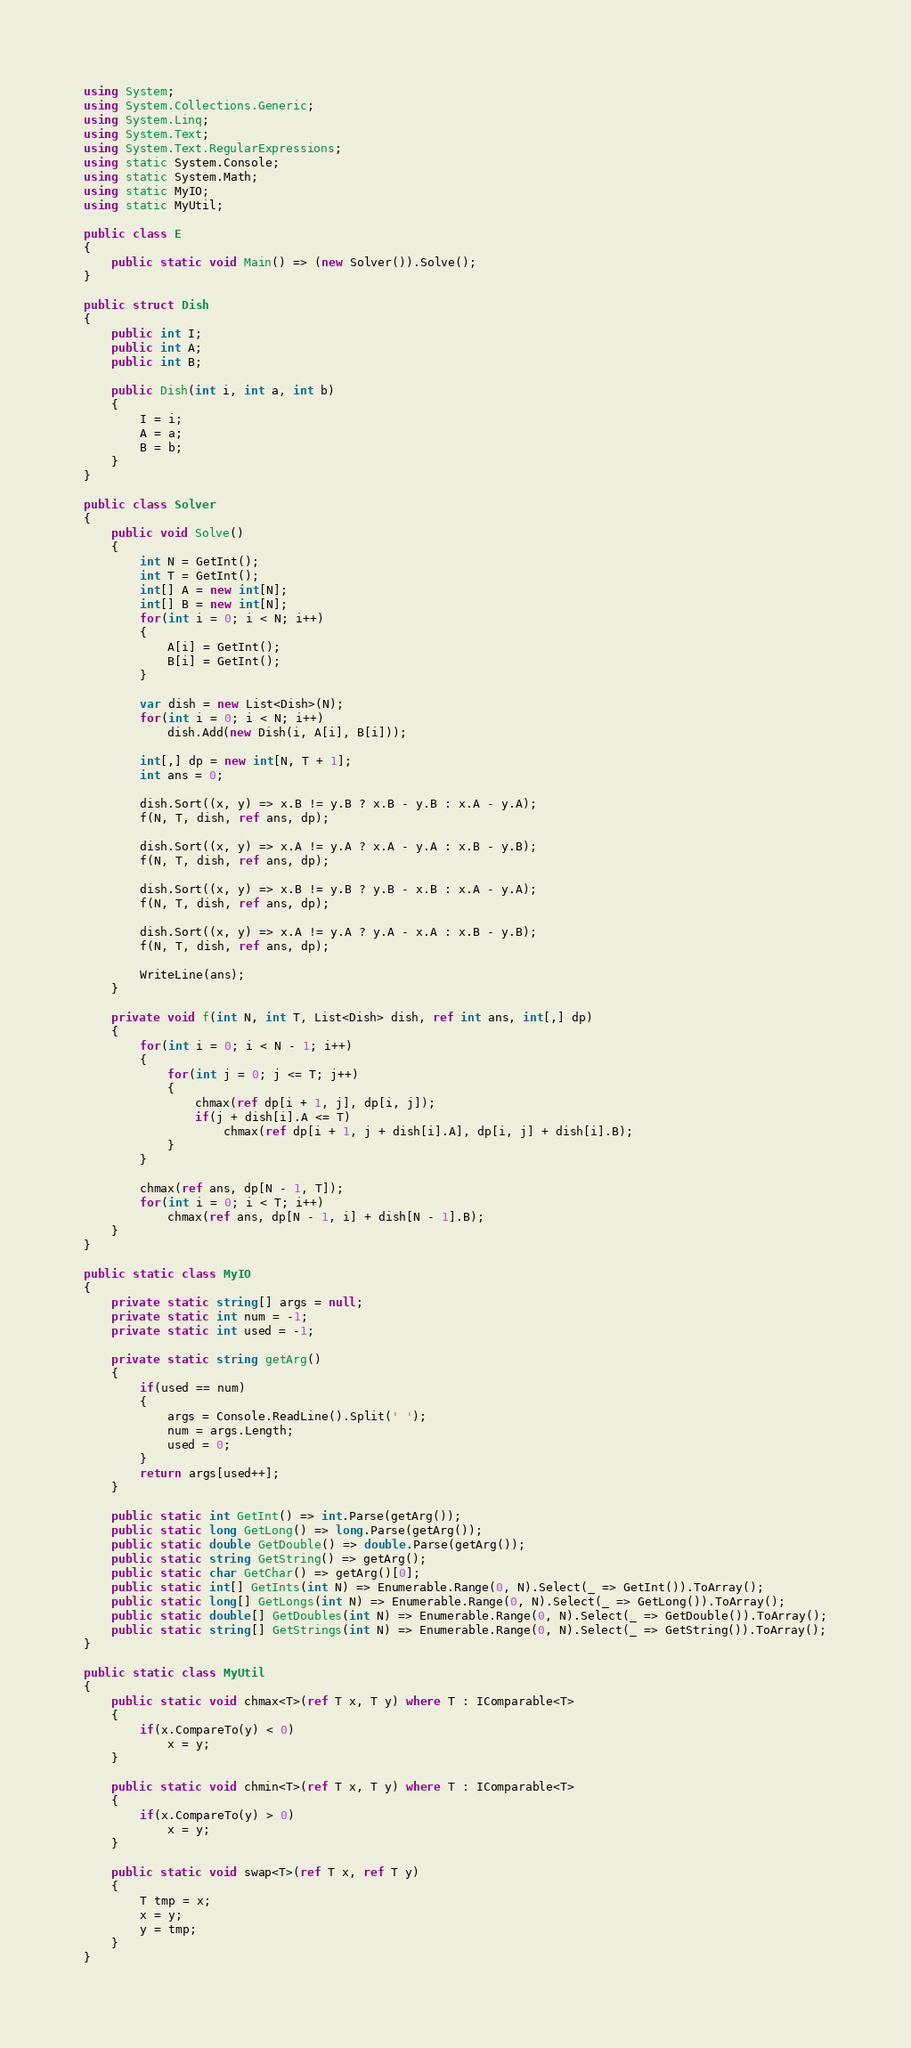<code> <loc_0><loc_0><loc_500><loc_500><_C#_>using System;
using System.Collections.Generic;
using System.Linq;
using System.Text;
using System.Text.RegularExpressions;
using static System.Console;
using static System.Math;
using static MyIO;
using static MyUtil;

public class E
{
	public static void Main() => (new Solver()).Solve();
}

public struct Dish
{
	public int I;
	public int A;
	public int B;

	public Dish(int i, int a, int b)
	{
		I = i;
		A = a;
		B = b;
	}
}

public class Solver
{
	public void Solve()
	{
		int N = GetInt();
		int T = GetInt();
		int[] A = new int[N];
		int[] B = new int[N];
		for(int i = 0; i < N; i++)
		{
			A[i] = GetInt();
			B[i] = GetInt();
		}

		var dish = new List<Dish>(N);
		for(int i = 0; i < N; i++)
			dish.Add(new Dish(i, A[i], B[i]));

		int[,] dp = new int[N, T + 1];
		int ans = 0;		

		dish.Sort((x, y) => x.B != y.B ? x.B - y.B : x.A - y.A);
		f(N, T, dish, ref ans, dp);

		dish.Sort((x, y) => x.A != y.A ? x.A - y.A : x.B - y.B);
		f(N, T, dish, ref ans, dp);
		
		dish.Sort((x, y) => x.B != y.B ? y.B - x.B : x.A - y.A);
		f(N, T, dish, ref ans, dp);

		dish.Sort((x, y) => x.A != y.A ? y.A - x.A : x.B - y.B);
		f(N, T, dish, ref ans, dp);

		WriteLine(ans);		
	}

	private void f(int N, int T, List<Dish> dish, ref int ans, int[,] dp)
	{
		for(int i = 0; i < N - 1; i++)
		{
			for(int j = 0; j <= T; j++)
			{
				chmax(ref dp[i + 1, j], dp[i, j]);
				if(j + dish[i].A <= T)
					chmax(ref dp[i + 1, j + dish[i].A], dp[i, j] + dish[i].B);
			}
		}

		chmax(ref ans, dp[N - 1, T]);
		for(int i = 0; i < T; i++)
			chmax(ref ans, dp[N - 1, i] + dish[N - 1].B);
	}
}

public static class MyIO
{
	private static string[] args = null;
	private static int num = -1;
	private static int used = -1;

	private static string getArg()
	{
		if(used == num)
		{
			args = Console.ReadLine().Split(' ');
			num = args.Length;
			used = 0;
		}
		return args[used++];
	}

	public static int GetInt() => int.Parse(getArg());
	public static long GetLong() => long.Parse(getArg());
	public static double GetDouble() => double.Parse(getArg());
	public static string GetString() => getArg();
	public static char GetChar() => getArg()[0];
	public static int[] GetInts(int N) => Enumerable.Range(0, N).Select(_ => GetInt()).ToArray();
	public static long[] GetLongs(int N) => Enumerable.Range(0, N).Select(_ => GetLong()).ToArray();
	public static double[] GetDoubles(int N) => Enumerable.Range(0, N).Select(_ => GetDouble()).ToArray();
	public static string[] GetStrings(int N) => Enumerable.Range(0, N).Select(_ => GetString()).ToArray();
}

public static class MyUtil
{
	public static void chmax<T>(ref T x, T y) where T : IComparable<T>
	{
		if(x.CompareTo(y) < 0)
			x = y;
	}

	public static void chmin<T>(ref T x, T y) where T : IComparable<T>
	{
		if(x.CompareTo(y) > 0)
			x = y;
	}

	public static void swap<T>(ref T x, ref T y)
	{
		T tmp = x;
		x = y;
		y = tmp;
	}
}</code> 